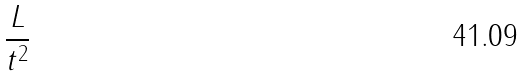<formula> <loc_0><loc_0><loc_500><loc_500>\frac { L } { t ^ { 2 } }</formula> 